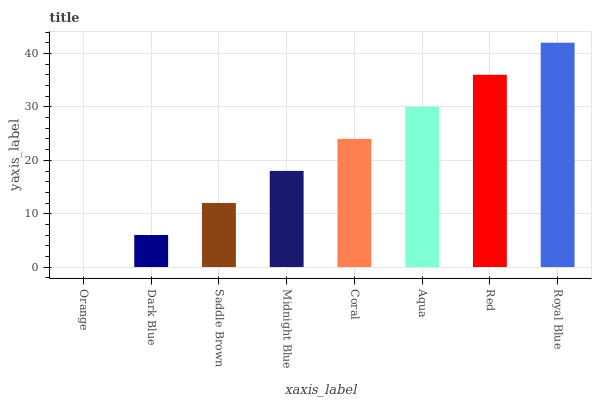Is Orange the minimum?
Answer yes or no. Yes. Is Royal Blue the maximum?
Answer yes or no. Yes. Is Dark Blue the minimum?
Answer yes or no. No. Is Dark Blue the maximum?
Answer yes or no. No. Is Dark Blue greater than Orange?
Answer yes or no. Yes. Is Orange less than Dark Blue?
Answer yes or no. Yes. Is Orange greater than Dark Blue?
Answer yes or no. No. Is Dark Blue less than Orange?
Answer yes or no. No. Is Coral the high median?
Answer yes or no. Yes. Is Midnight Blue the low median?
Answer yes or no. Yes. Is Saddle Brown the high median?
Answer yes or no. No. Is Dark Blue the low median?
Answer yes or no. No. 